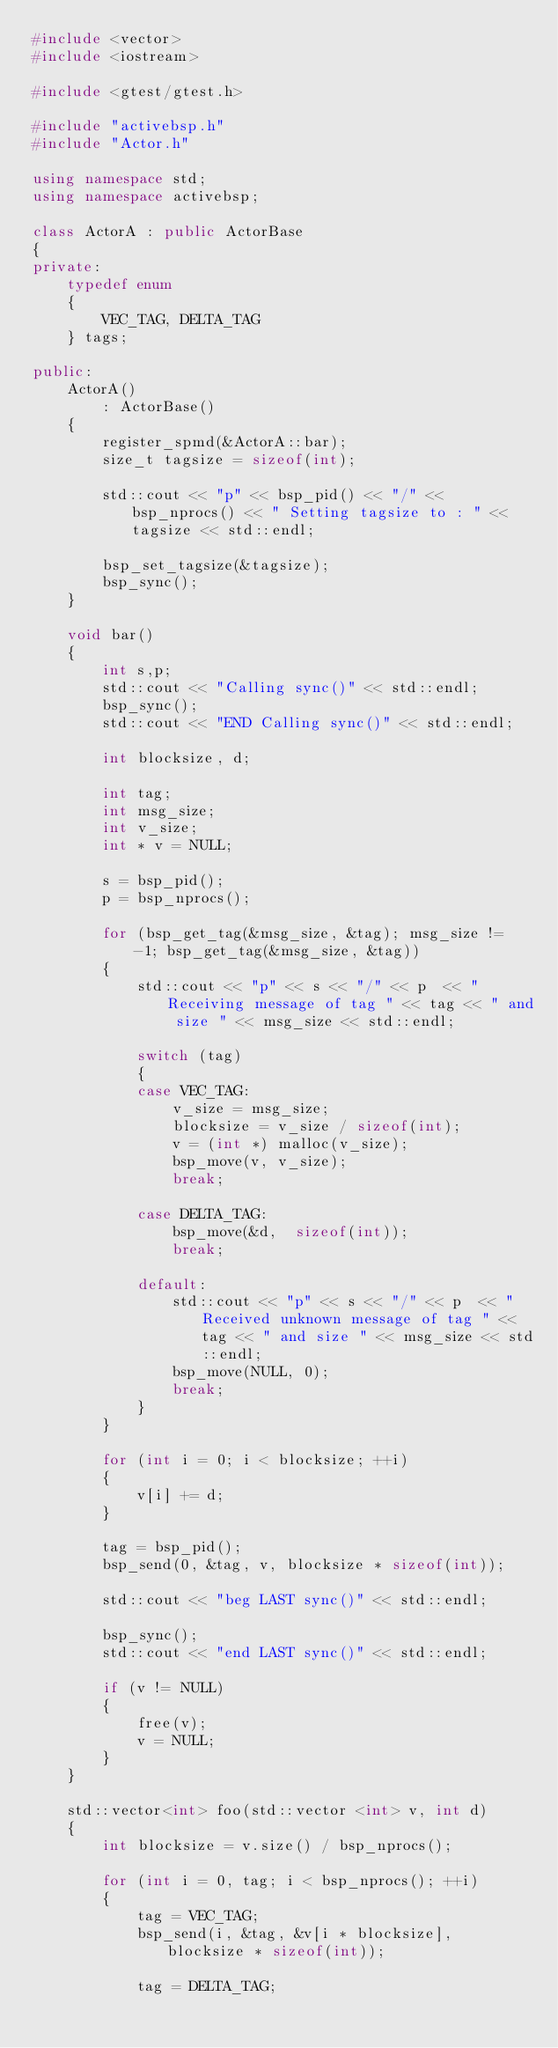Convert code to text. <code><loc_0><loc_0><loc_500><loc_500><_C++_>#include <vector>
#include <iostream>

#include <gtest/gtest.h>

#include "activebsp.h"
#include "Actor.h"

using namespace std;
using namespace activebsp;

class ActorA : public ActorBase
{
private:
    typedef enum
    {
        VEC_TAG, DELTA_TAG
    } tags;

public:
    ActorA()
        : ActorBase()
    {
        register_spmd(&ActorA::bar);
        size_t tagsize = sizeof(int);

        std::cout << "p" << bsp_pid() << "/" << bsp_nprocs() << " Setting tagsize to : " << tagsize << std::endl;

        bsp_set_tagsize(&tagsize);
        bsp_sync();
    }

    void bar()
    {
        int s,p;
        std::cout << "Calling sync()" << std::endl;
        bsp_sync();
        std::cout << "END Calling sync()" << std::endl;

        int blocksize, d;

        int tag;
        int msg_size;
        int v_size;
        int * v = NULL;

        s = bsp_pid();
        p = bsp_nprocs();

        for (bsp_get_tag(&msg_size, &tag); msg_size != -1; bsp_get_tag(&msg_size, &tag))
        {
            std::cout << "p" << s << "/" << p  << " Receiving message of tag " << tag << " and size " << msg_size << std::endl;

            switch (tag)
            {
            case VEC_TAG:
                v_size = msg_size;
                blocksize = v_size / sizeof(int);
                v = (int *) malloc(v_size);
                bsp_move(v, v_size);
                break;

            case DELTA_TAG:
                bsp_move(&d,  sizeof(int));
                break;

            default:
                std::cout << "p" << s << "/" << p  << " Received unknown message of tag " << tag << " and size " << msg_size << std::endl;
                bsp_move(NULL, 0);
                break;
            }
        }

        for (int i = 0; i < blocksize; ++i)
        {
            v[i] += d;
        }

        tag = bsp_pid();
        bsp_send(0, &tag, v, blocksize * sizeof(int));

        std::cout << "beg LAST sync()" << std::endl;

        bsp_sync();
        std::cout << "end LAST sync()" << std::endl;

        if (v != NULL)
        {
            free(v);
            v = NULL;
        }
    }

    std::vector<int> foo(std::vector <int> v, int d)
    {
        int blocksize = v.size() / bsp_nprocs();

        for (int i = 0, tag; i < bsp_nprocs(); ++i)
        {
            tag = VEC_TAG;
            bsp_send(i, &tag, &v[i * blocksize], blocksize * sizeof(int));

            tag = DELTA_TAG;</code> 